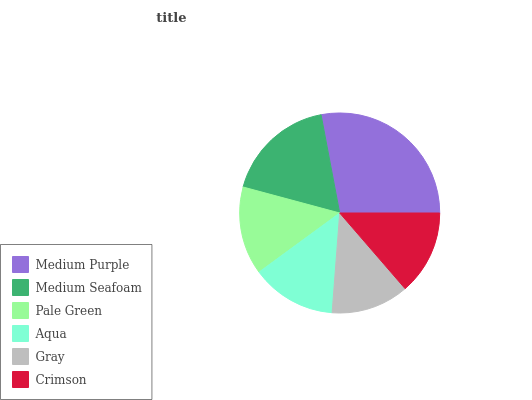Is Gray the minimum?
Answer yes or no. Yes. Is Medium Purple the maximum?
Answer yes or no. Yes. Is Medium Seafoam the minimum?
Answer yes or no. No. Is Medium Seafoam the maximum?
Answer yes or no. No. Is Medium Purple greater than Medium Seafoam?
Answer yes or no. Yes. Is Medium Seafoam less than Medium Purple?
Answer yes or no. Yes. Is Medium Seafoam greater than Medium Purple?
Answer yes or no. No. Is Medium Purple less than Medium Seafoam?
Answer yes or no. No. Is Pale Green the high median?
Answer yes or no. Yes. Is Aqua the low median?
Answer yes or no. Yes. Is Medium Seafoam the high median?
Answer yes or no. No. Is Medium Purple the low median?
Answer yes or no. No. 